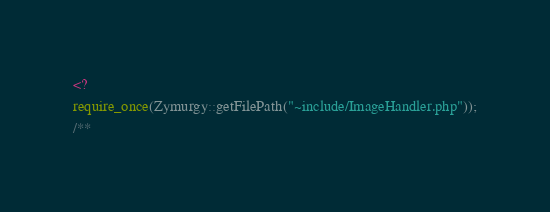<code> <loc_0><loc_0><loc_500><loc_500><_PHP_><?
require_once(Zymurgy::getFilePath("~include/ImageHandler.php"));
/**</code> 